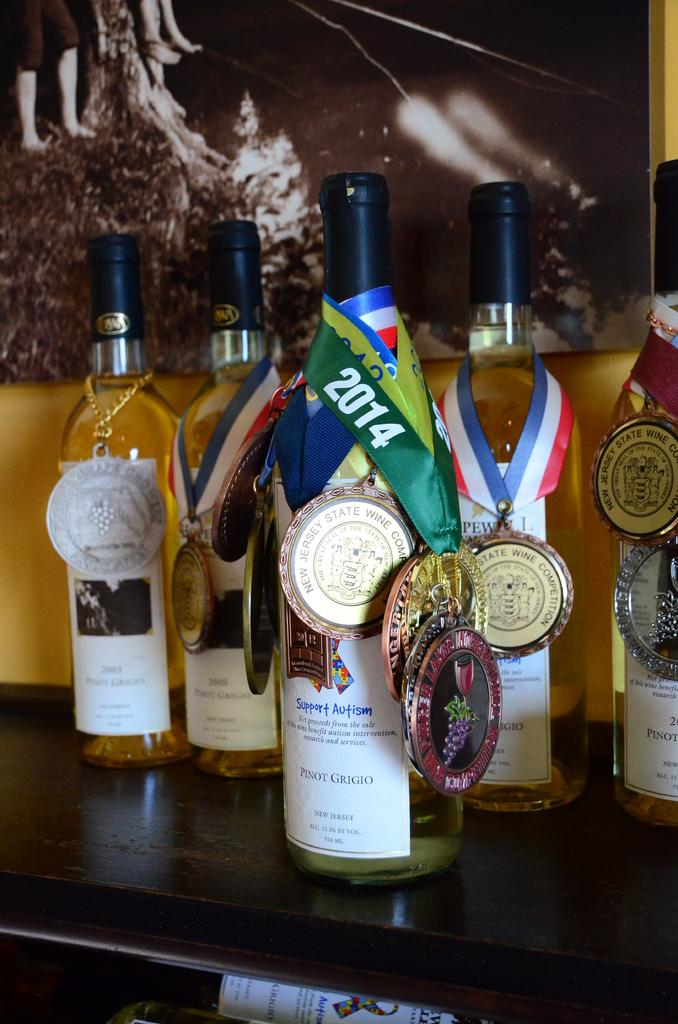<image>
Create a compact narrative representing the image presented. the word 2014 that is on a bottle 